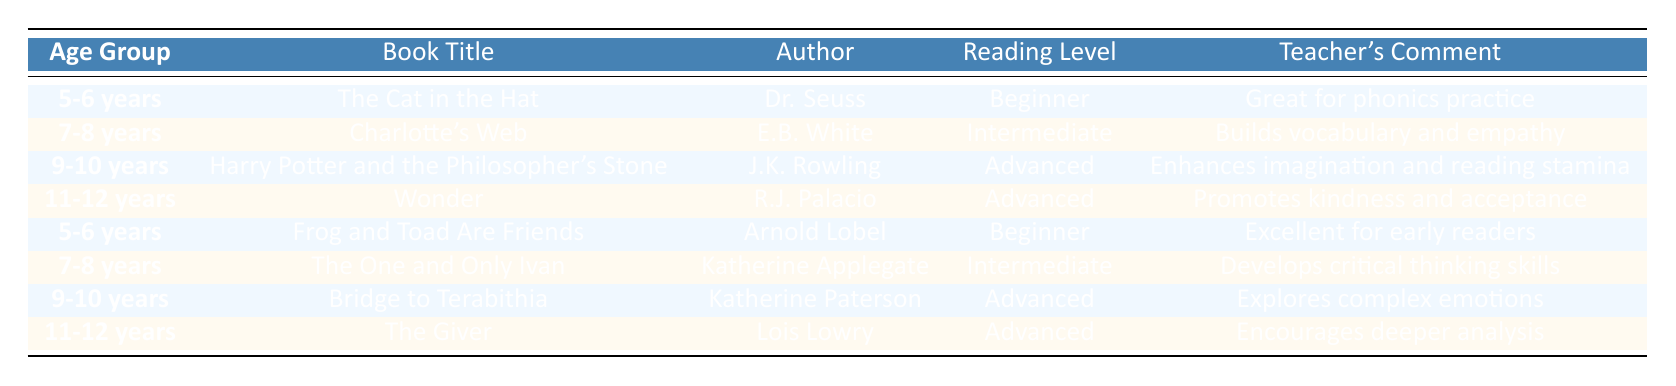What book is recommended for 5-6 years? The table indicates two books for the 5-6 years age group: "The Cat in the Hat" by Dr. Seuss and "Frog and Toad Are Friends" by Arnold Lobel.
Answer: "The Cat in the Hat" and "Frog and Toad Are Friends" Which author wrote "Wonder"? The table shows that "Wonder" is written by R.J. Palacio, as listed in the row for the 11-12 years age group.
Answer: R.J. Palacio True or False: "Charlotte's Web" is suitable for advanced readers. According to the table, "Charlotte's Web" is classified as intermediate reading level, which means it is not suitable for advanced readers. Therefore, the statement is false.
Answer: False Which age group has the most advanced book titles? The advanced reading levels are found in the 9-10 years and 11-12 years age groups, with the books "Harry Potter and the Philosopher's Stone," "Bridge to Terabithia," "Wonder," and "The Giver." There are four advanced titles across these two age groups.
Answer: 9-10 years and 11-12 years Which book is recommended for developing critical thinking skills? "The One and Only Ivan" by Katherine Applegate is listed in the 7-8 years age group, with a teacher's comment indicating its focus on developing critical thinking skills.
Answer: The One and Only Ivan What is the reading level of "Bridge to Terabithia" and what is the teacher's comment? "Bridge to Terabithia" is categorized as an advanced reading level and the teacher’s comment states it explores complex emotions.
Answer: Advanced; explores complex emotions True or False: All books recommended for the 5-6 age group are beginner level. The table indicates that both books for the 5-6 age group, "The Cat in the Hat" and "Frog and Toad Are Friends," are indeed labeled as beginner reading levels. Therefore, the statement is true.
Answer: True What is the total number of books recommended for children aged 7-8 years? The table lists two books recommended for the 7-8 age group, which are "Charlotte's Web" and "The One and Only Ivan." Therefore, the total is 2.
Answer: 2 